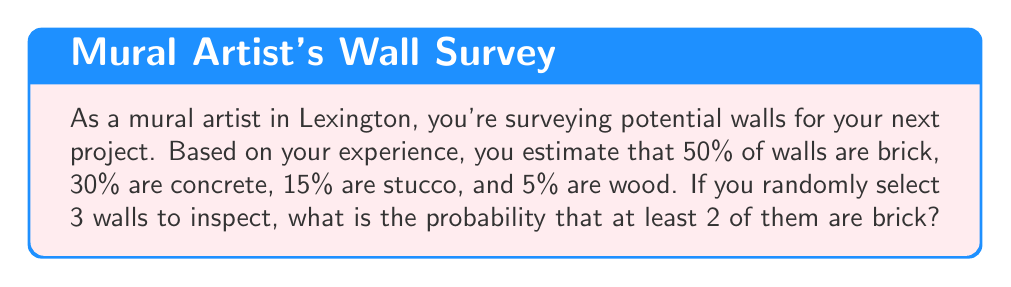Can you solve this math problem? To solve this problem, we'll use the binomial probability distribution. Let's break it down step-by-step:

1) First, we need to calculate the probability of selecting a brick wall:
   $p(\text{brick}) = 0.50$

2) The probability of not selecting a brick wall is:
   $p(\text{not brick}) = 1 - 0.50 = 0.50$

3) We want the probability of at least 2 out of 3 walls being brick. This can happen in two ways:
   - Exactly 2 out of 3 are brick
   - All 3 are brick

4) Let's calculate these probabilities using the binomial probability formula:
   $$P(X = k) = \binom{n}{k} p^k (1-p)^{n-k}$$
   where $n$ is the number of trials, $k$ is the number of successes, and $p$ is the probability of success on each trial.

5) For exactly 2 out of 3 being brick:
   $$P(X = 2) = \binom{3}{2} (0.50)^2 (0.50)^1 = 3 \cdot 0.25 \cdot 0.50 = 0.375$$

6) For all 3 being brick:
   $$P(X = 3) = \binom{3}{3} (0.50)^3 = 1 \cdot 0.125 = 0.125$$

7) The probability of at least 2 out of 3 being brick is the sum of these probabilities:
   $$P(X \geq 2) = P(X = 2) + P(X = 3) = 0.375 + 0.125 = 0.500$$
Answer: The probability of at least 2 out of 3 randomly selected walls being brick is 0.500 or 50%. 